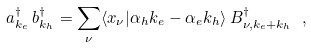Convert formula to latex. <formula><loc_0><loc_0><loc_500><loc_500>a _ { k _ { e } } ^ { \dag } \, b _ { k _ { h } } ^ { \dag } = \sum _ { \nu } \langle x _ { \nu } | \alpha _ { h } k _ { e } - \alpha _ { e } k _ { h } \rangle \, B _ { \nu , k _ { e } + k _ { h } } ^ { \dag } \ ,</formula> 